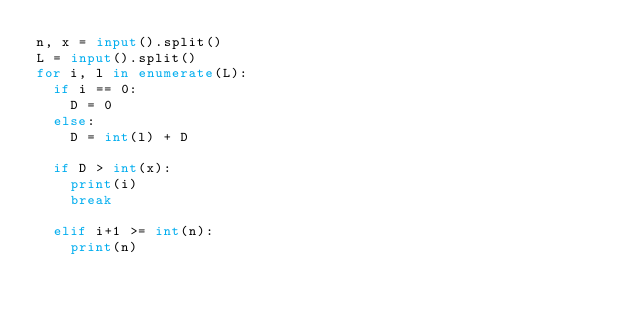Convert code to text. <code><loc_0><loc_0><loc_500><loc_500><_Python_>n, x = input().split()
L = input().split()
for i, l in enumerate(L):
  if i == 0:
    D = 0
  else:
    D = int(l) + D
    
  if D > int(x):
    print(i)
    break
    
  elif i+1 >= int(n):
    print(n)</code> 